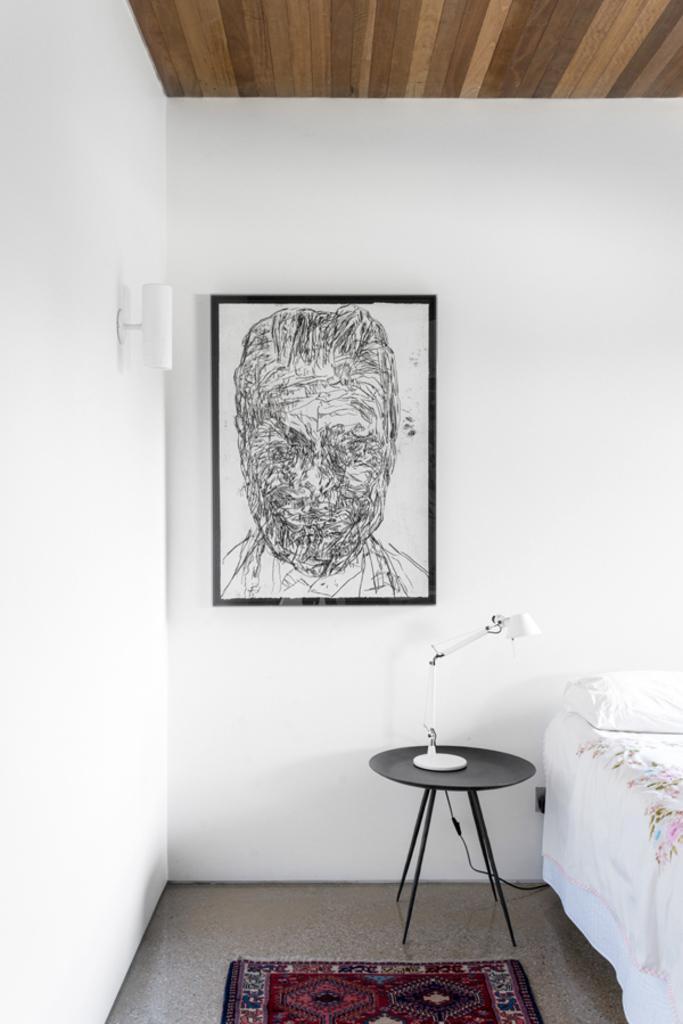How would you summarize this image in a sentence or two? This picture shows photo frame on the wall and we see a bed and a pillow and a table lamp on the table and we see carpet on the floor and a light to the wall. 